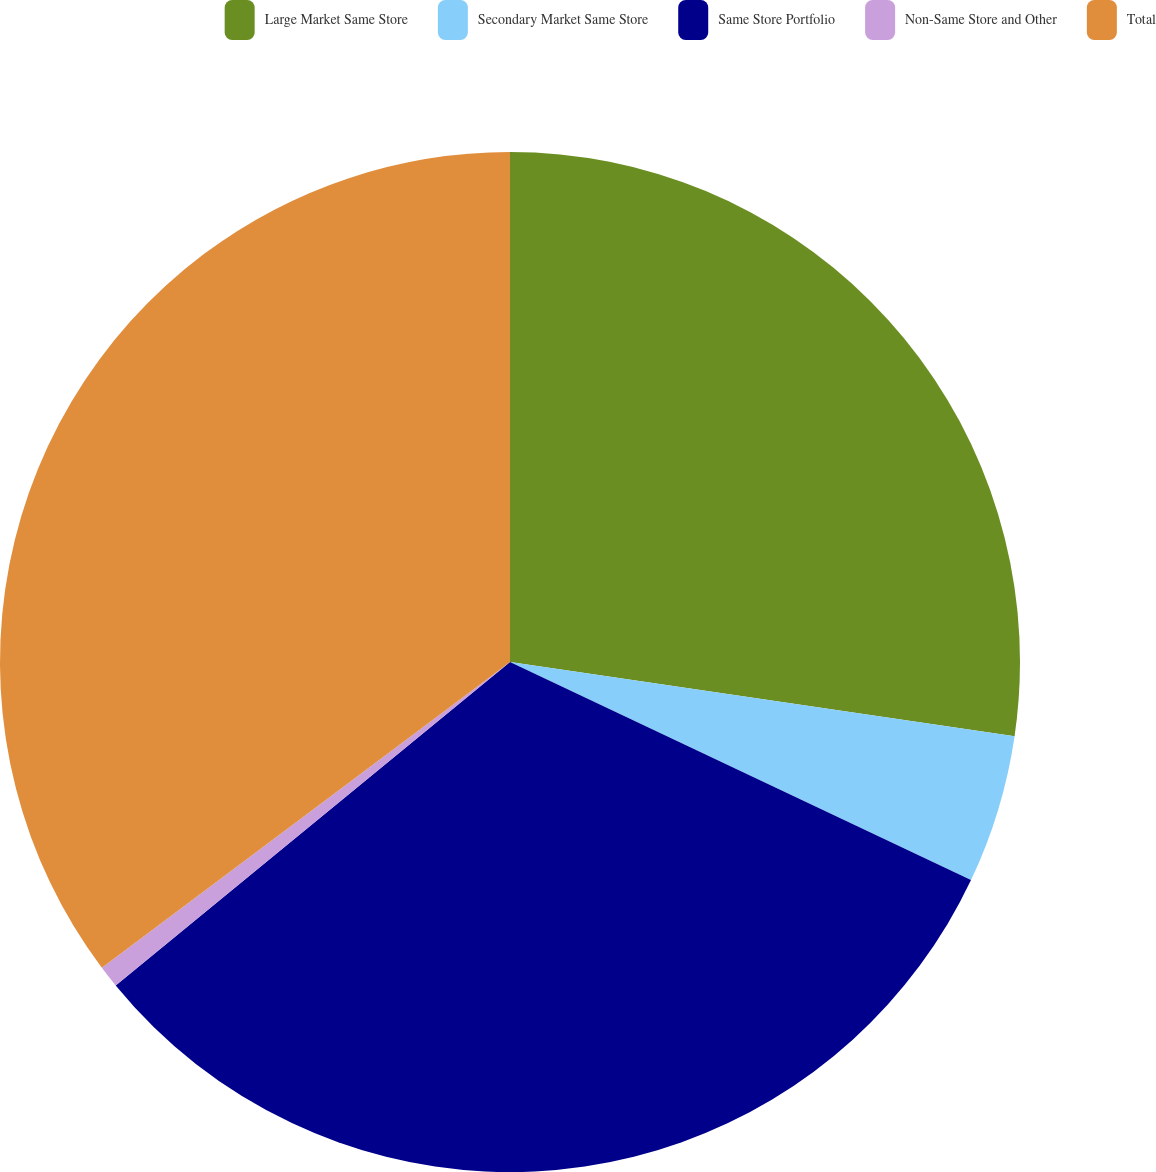Convert chart. <chart><loc_0><loc_0><loc_500><loc_500><pie_chart><fcel>Large Market Same Store<fcel>Secondary Market Same Store<fcel>Same Store Portfolio<fcel>Non-Same Store and Other<fcel>Total<nl><fcel>27.32%<fcel>4.71%<fcel>32.03%<fcel>0.7%<fcel>35.23%<nl></chart> 